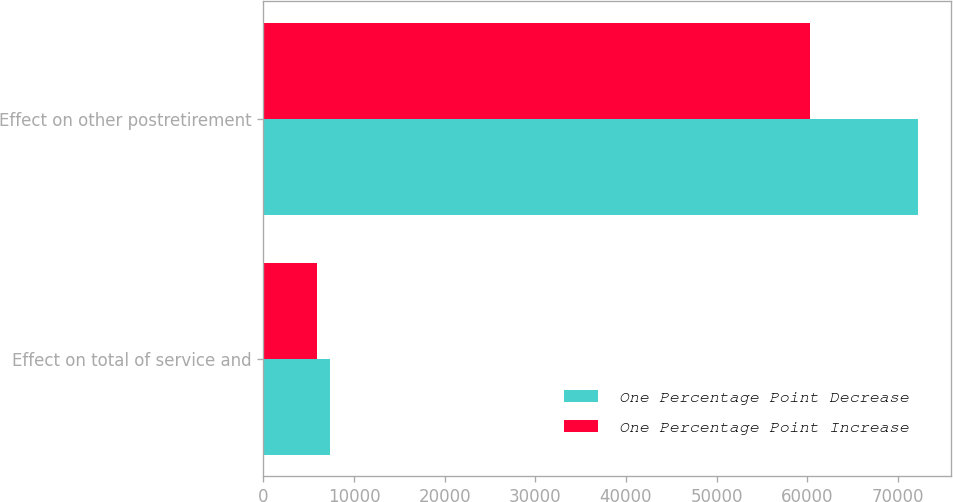<chart> <loc_0><loc_0><loc_500><loc_500><stacked_bar_chart><ecel><fcel>Effect on total of service and<fcel>Effect on other postretirement<nl><fcel>One Percentage Point Decrease<fcel>7367<fcel>72238<nl><fcel>One Percentage Point Increase<fcel>5974<fcel>60261<nl></chart> 